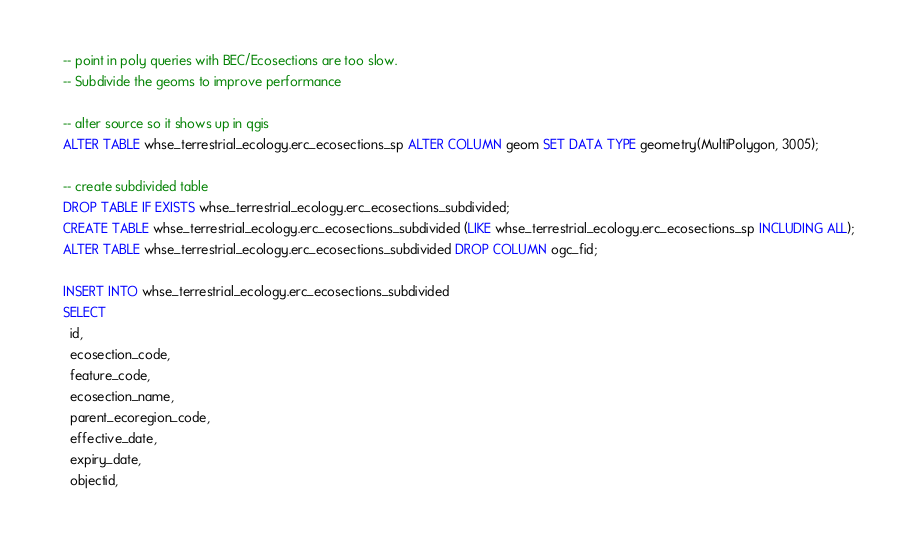<code> <loc_0><loc_0><loc_500><loc_500><_SQL_>-- point in poly queries with BEC/Ecosections are too slow.
-- Subdivide the geoms to improve performance

-- alter source so it shows up in qgis
ALTER TABLE whse_terrestrial_ecology.erc_ecosections_sp ALTER COLUMN geom SET DATA TYPE geometry(MultiPolygon, 3005);

-- create subdivided table
DROP TABLE IF EXISTS whse_terrestrial_ecology.erc_ecosections_subdivided;
CREATE TABLE whse_terrestrial_ecology.erc_ecosections_subdivided (LIKE whse_terrestrial_ecology.erc_ecosections_sp INCLUDING ALL);
ALTER TABLE whse_terrestrial_ecology.erc_ecosections_subdivided DROP COLUMN ogc_fid;

INSERT INTO whse_terrestrial_ecology.erc_ecosections_subdivided
SELECT
  id,
  ecosection_code,
  feature_code,
  ecosection_name,
  parent_ecoregion_code,
  effective_date,
  expiry_date,
  objectid,</code> 